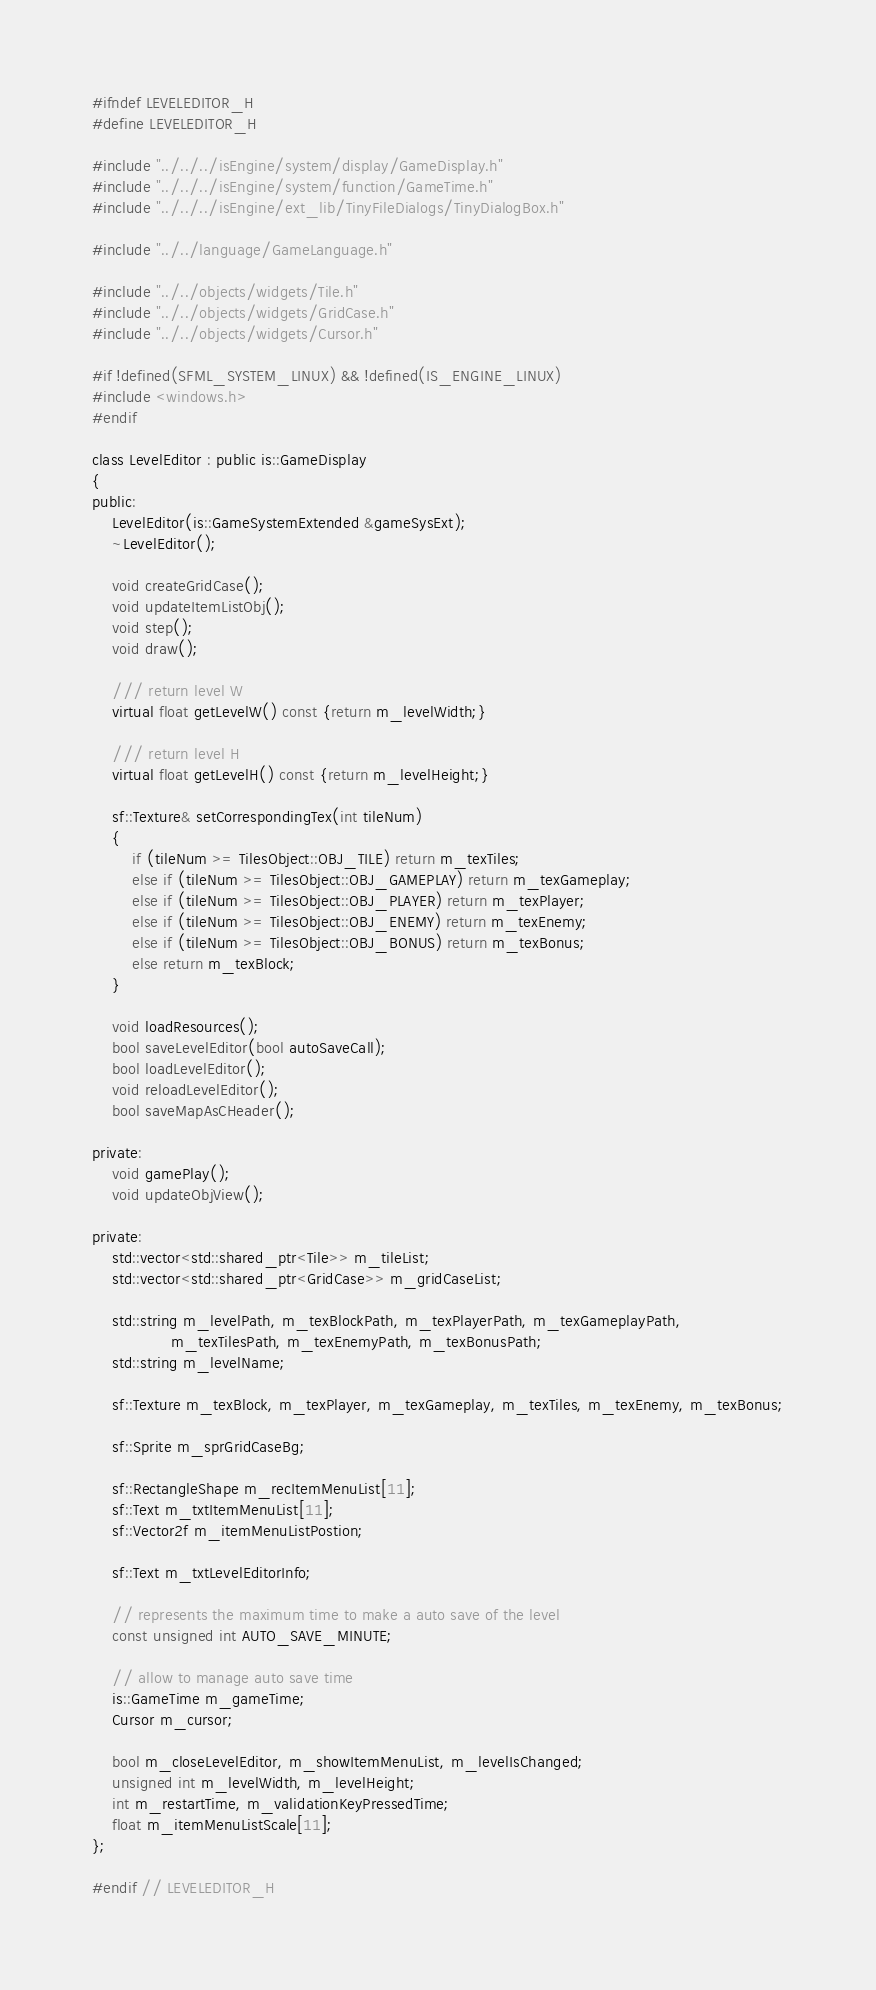<code> <loc_0><loc_0><loc_500><loc_500><_C_>#ifndef LEVELEDITOR_H
#define LEVELEDITOR_H

#include "../../../isEngine/system/display/GameDisplay.h"
#include "../../../isEngine/system/function/GameTime.h"
#include "../../../isEngine/ext_lib/TinyFileDialogs/TinyDialogBox.h"

#include "../../language/GameLanguage.h"

#include "../../objects/widgets/Tile.h"
#include "../../objects/widgets/GridCase.h"
#include "../../objects/widgets/Cursor.h"

#if !defined(SFML_SYSTEM_LINUX) && !defined(IS_ENGINE_LINUX)
#include <windows.h>
#endif

class LevelEditor : public is::GameDisplay
{
public:
    LevelEditor(is::GameSystemExtended &gameSysExt);
    ~LevelEditor();

    void createGridCase();
    void updateItemListObj();
    void step();
    void draw();

    /// return level W
    virtual float getLevelW() const {return m_levelWidth;}

    /// return level H
    virtual float getLevelH() const {return m_levelHeight;}

    sf::Texture& setCorrespondingTex(int tileNum)
    {
        if (tileNum >= TilesObject::OBJ_TILE) return m_texTiles;
        else if (tileNum >= TilesObject::OBJ_GAMEPLAY) return m_texGameplay;
        else if (tileNum >= TilesObject::OBJ_PLAYER) return m_texPlayer;
        else if (tileNum >= TilesObject::OBJ_ENEMY) return m_texEnemy;
        else if (tileNum >= TilesObject::OBJ_BONUS) return m_texBonus;
        else return m_texBlock;
    }

    void loadResources();
    bool saveLevelEditor(bool autoSaveCall);
    bool loadLevelEditor();
    void reloadLevelEditor();
    bool saveMapAsCHeader();

private:
    void gamePlay();
    void updateObjView();

private:
    std::vector<std::shared_ptr<Tile>> m_tileList;
    std::vector<std::shared_ptr<GridCase>> m_gridCaseList;

    std::string m_levelPath, m_texBlockPath, m_texPlayerPath, m_texGameplayPath,
                m_texTilesPath, m_texEnemyPath, m_texBonusPath;
    std::string m_levelName;

    sf::Texture m_texBlock, m_texPlayer, m_texGameplay, m_texTiles, m_texEnemy, m_texBonus;

    sf::Sprite m_sprGridCaseBg;

    sf::RectangleShape m_recItemMenuList[11];
    sf::Text m_txtItemMenuList[11];
    sf::Vector2f m_itemMenuListPostion;

    sf::Text m_txtLevelEditorInfo;

    // represents the maximum time to make a auto save of the level
    const unsigned int AUTO_SAVE_MINUTE;

    // allow to manage auto save time
    is::GameTime m_gameTime;
    Cursor m_cursor;

    bool m_closeLevelEditor, m_showItemMenuList, m_levelIsChanged;
    unsigned int m_levelWidth, m_levelHeight;
    int m_restartTime, m_validationKeyPressedTime;
    float m_itemMenuListScale[11];
};

#endif // LEVELEDITOR_H
</code> 